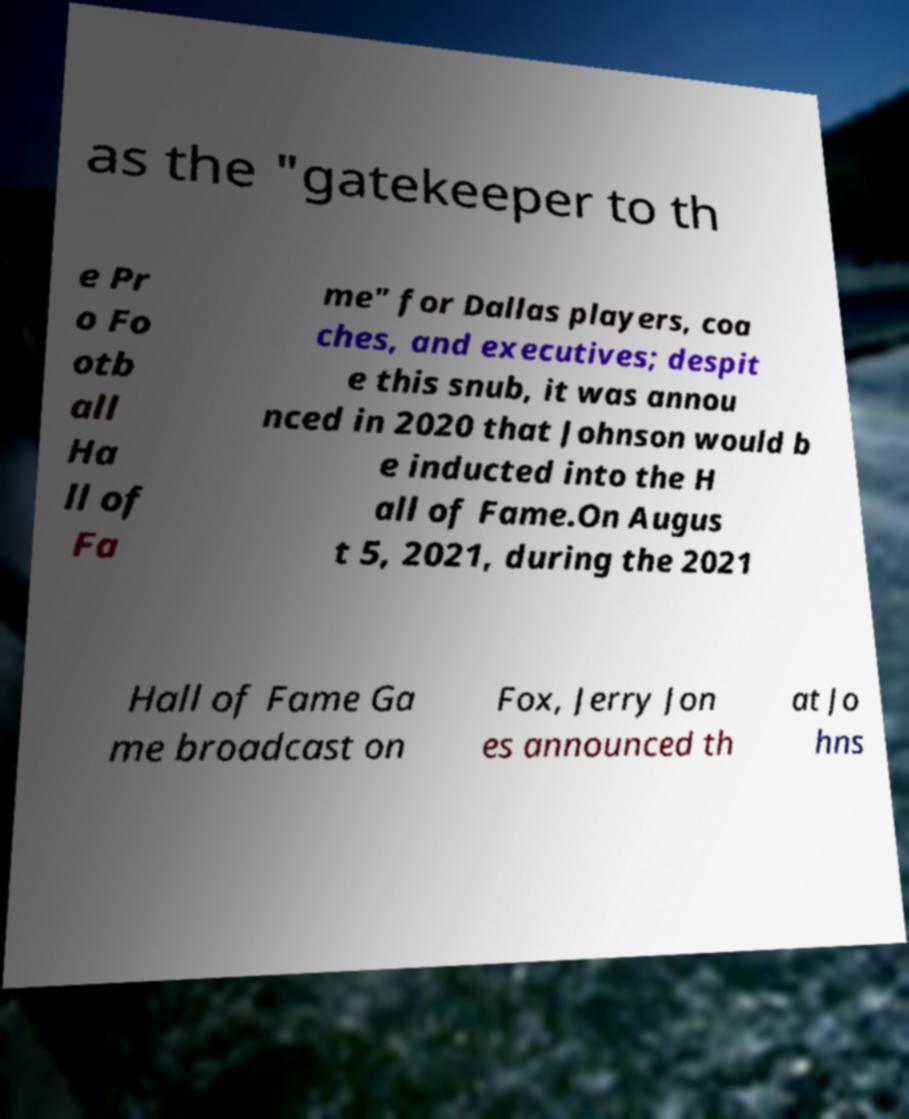Please identify and transcribe the text found in this image. as the "gatekeeper to th e Pr o Fo otb all Ha ll of Fa me" for Dallas players, coa ches, and executives; despit e this snub, it was annou nced in 2020 that Johnson would b e inducted into the H all of Fame.On Augus t 5, 2021, during the 2021 Hall of Fame Ga me broadcast on Fox, Jerry Jon es announced th at Jo hns 